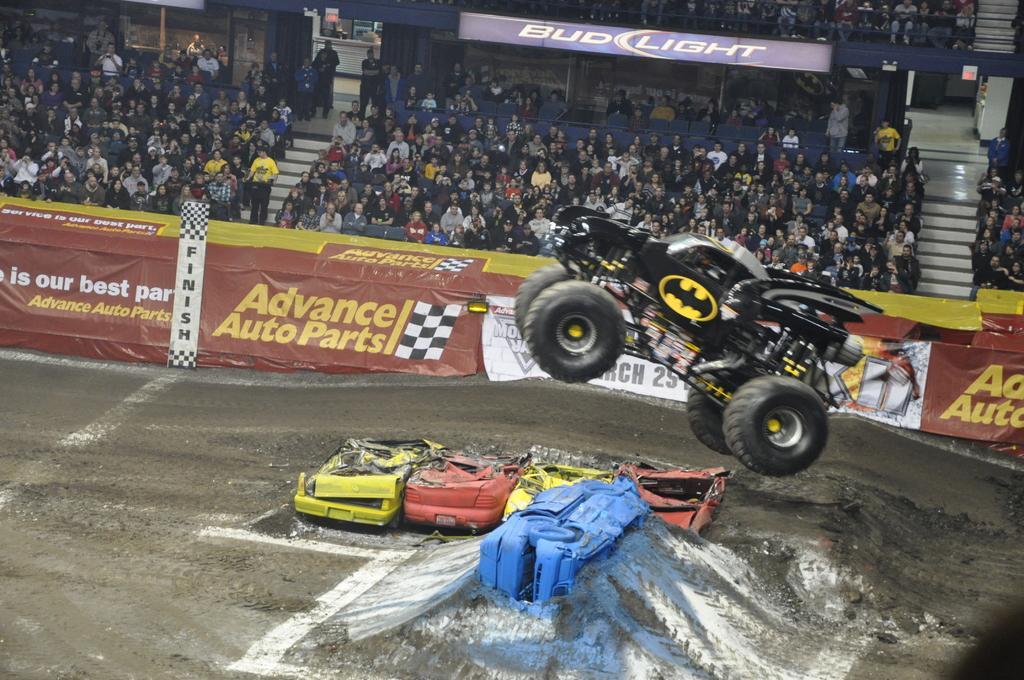In one or two sentences, can you explain what this image depicts? In this image we can see vehicles. In the back there are banners with text. Also there are many people sitting. Also there are steps. And few people are standing. 